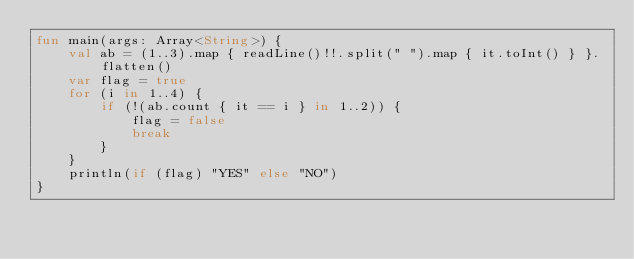Convert code to text. <code><loc_0><loc_0><loc_500><loc_500><_Kotlin_>fun main(args: Array<String>) {
    val ab = (1..3).map { readLine()!!.split(" ").map { it.toInt() } }.flatten()
    var flag = true
    for (i in 1..4) {
        if (!(ab.count { it == i } in 1..2)) {
            flag = false
            break
        }
    }
    println(if (flag) "YES" else "NO")
}</code> 